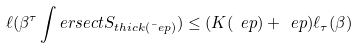Convert formula to latex. <formula><loc_0><loc_0><loc_500><loc_500>\ell ( \beta ^ { \tau } \int e r s e c t S _ { t h i c k ( \bar { \ } e p ) } ) \leq ( K ( \ e p ) + \ e p ) \ell _ { \tau } ( \beta )</formula> 